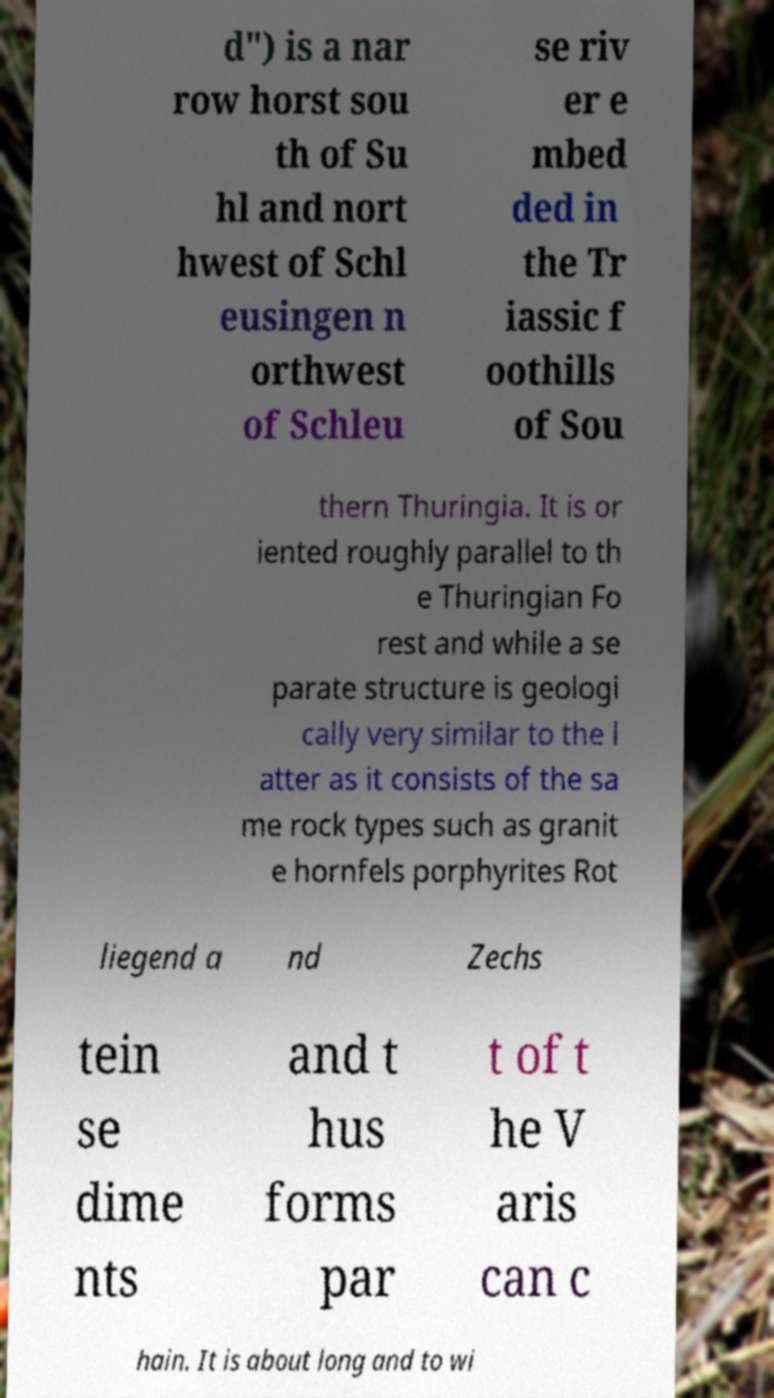Can you accurately transcribe the text from the provided image for me? d") is a nar row horst sou th of Su hl and nort hwest of Schl eusingen n orthwest of Schleu se riv er e mbed ded in the Tr iassic f oothills of Sou thern Thuringia. It is or iented roughly parallel to th e Thuringian Fo rest and while a se parate structure is geologi cally very similar to the l atter as it consists of the sa me rock types such as granit e hornfels porphyrites Rot liegend a nd Zechs tein se dime nts and t hus forms par t of t he V aris can c hain. It is about long and to wi 